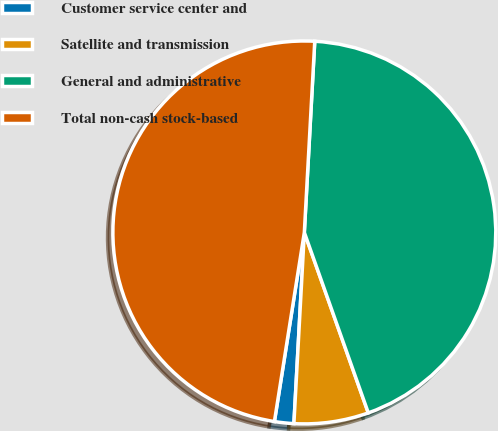Convert chart to OTSL. <chart><loc_0><loc_0><loc_500><loc_500><pie_chart><fcel>Customer service center and<fcel>Satellite and transmission<fcel>General and administrative<fcel>Total non-cash stock-based<nl><fcel>1.63%<fcel>6.29%<fcel>43.71%<fcel>48.37%<nl></chart> 